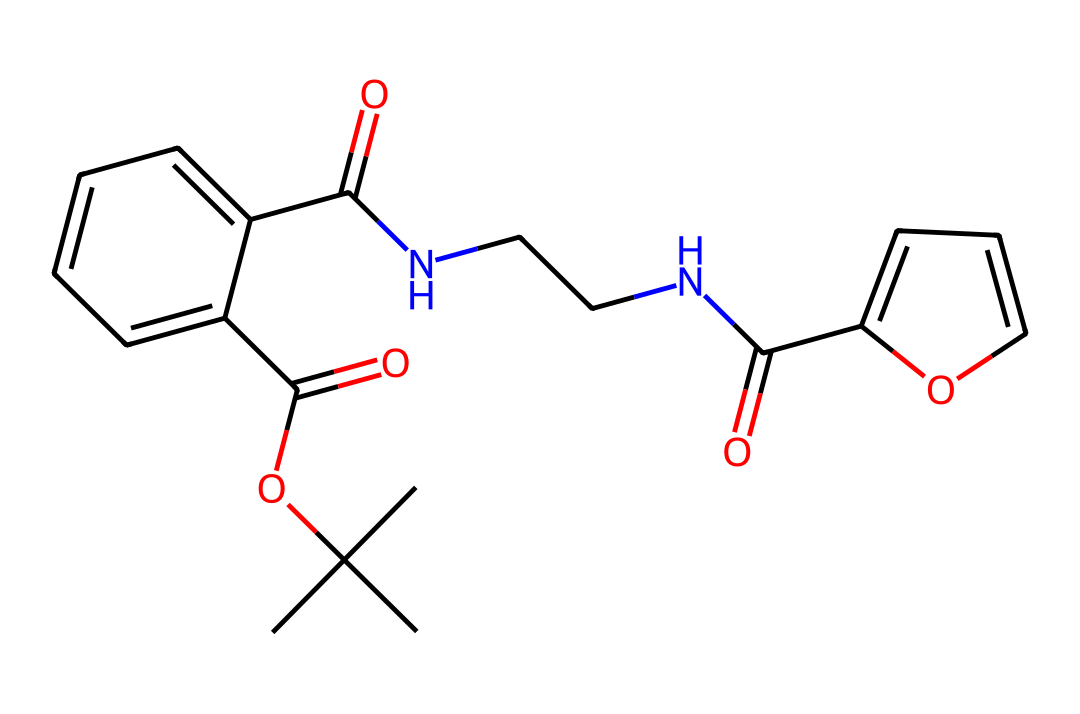which functional groups are present in this chemical? The chemical contains both ester (CC(C)(C)OC(=O)) and amide (C(=O)NCC) functional groups. The ester group is indicated by the presence of the carbonyl attached to an oxygen (–O–) and an alkyl chain. The amide group is identified by the carbonyl carbon (C=O) directly bonded to a nitrogen atom (N).
Answer: ester, amide how many rings are in the structure? By examining the structure, there are two rings present: one six-membered aromatic ring (C1=CC=CC=C1) and one five-membered ring (C2=CC=CO2). The presence of the cyclic structures indicates the rings.
Answer: two what is the total number of nitrogen atoms in the chemical? The structure has two nitrogen atoms present, identified by two occurrences of the nitrogen element (N) in the sequence.
Answer: two which part of the chemical indicates it may be used as a drug? The presence of nitrogen atoms suggesting pharmacological activity and the specific functional groups like amides, which are often found in pharmaceutical compounds, suggest this. It's a common design in drugs for biological activity.
Answer: nitrogen, amide what is the molecular weight of this chemical? To determine the molecular weight, we analyze the molecular formula derived from the SMILES notation. The formula for the structure can be determined through careful counting of each atom present. The molecular weight based on the counts concludes around 352.4 g/mol.
Answer: 352.4 g/mol 